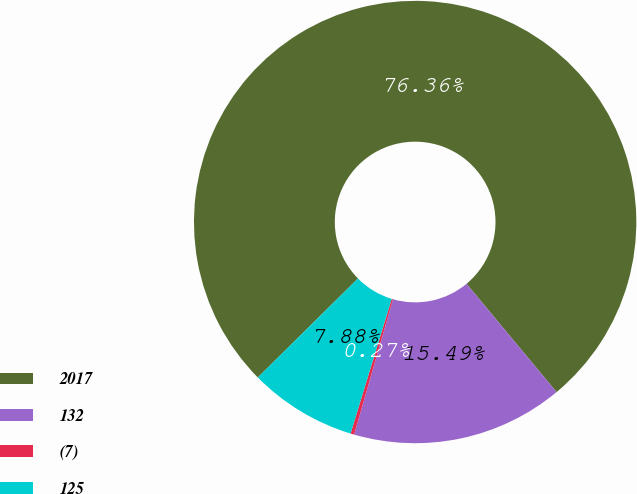Convert chart to OTSL. <chart><loc_0><loc_0><loc_500><loc_500><pie_chart><fcel>2017<fcel>132<fcel>(7)<fcel>125<nl><fcel>76.37%<fcel>15.49%<fcel>0.27%<fcel>7.88%<nl></chart> 